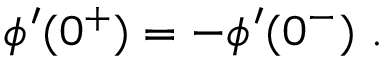<formula> <loc_0><loc_0><loc_500><loc_500>\phi ^ { \prime } ( 0 ^ { + } ) = - \phi ^ { \prime } ( 0 ^ { - } ) .</formula> 